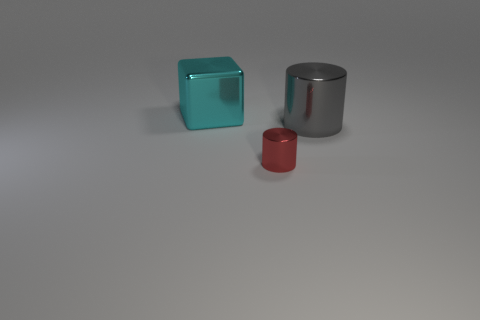What number of things have the same color as the cube?
Make the answer very short. 0. What is the size of the cyan object that is made of the same material as the tiny red cylinder?
Make the answer very short. Large. There is a thing that is left of the small red metallic cylinder; what is its shape?
Offer a terse response. Cube. What is the size of the other thing that is the same shape as the small red thing?
Make the answer very short. Large. What number of things are behind the large object that is right of the big metallic object to the left of the big gray cylinder?
Make the answer very short. 1. Is the number of tiny metallic cylinders behind the large metal cube the same as the number of blue matte cylinders?
Your answer should be compact. Yes. How many blocks are either tiny red rubber things or big cyan things?
Offer a very short reply. 1. Are there an equal number of large gray cylinders behind the cyan metal object and big cyan metallic cubes right of the small red shiny thing?
Your answer should be compact. Yes. The cube is what color?
Give a very brief answer. Cyan. What number of things are large objects in front of the large cyan thing or tiny brown rubber objects?
Offer a terse response. 1. 